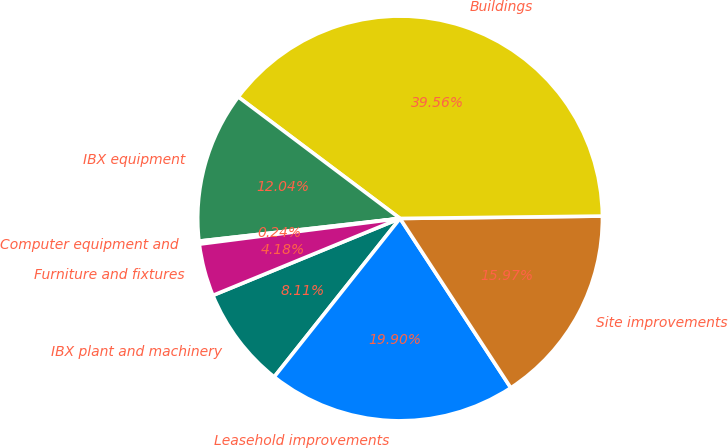<chart> <loc_0><loc_0><loc_500><loc_500><pie_chart><fcel>IBX plant and machinery<fcel>Leasehold improvements<fcel>Site improvements<fcel>Buildings<fcel>IBX equipment<fcel>Computer equipment and<fcel>Furniture and fixtures<nl><fcel>8.11%<fcel>19.9%<fcel>15.97%<fcel>39.56%<fcel>12.04%<fcel>0.24%<fcel>4.18%<nl></chart> 